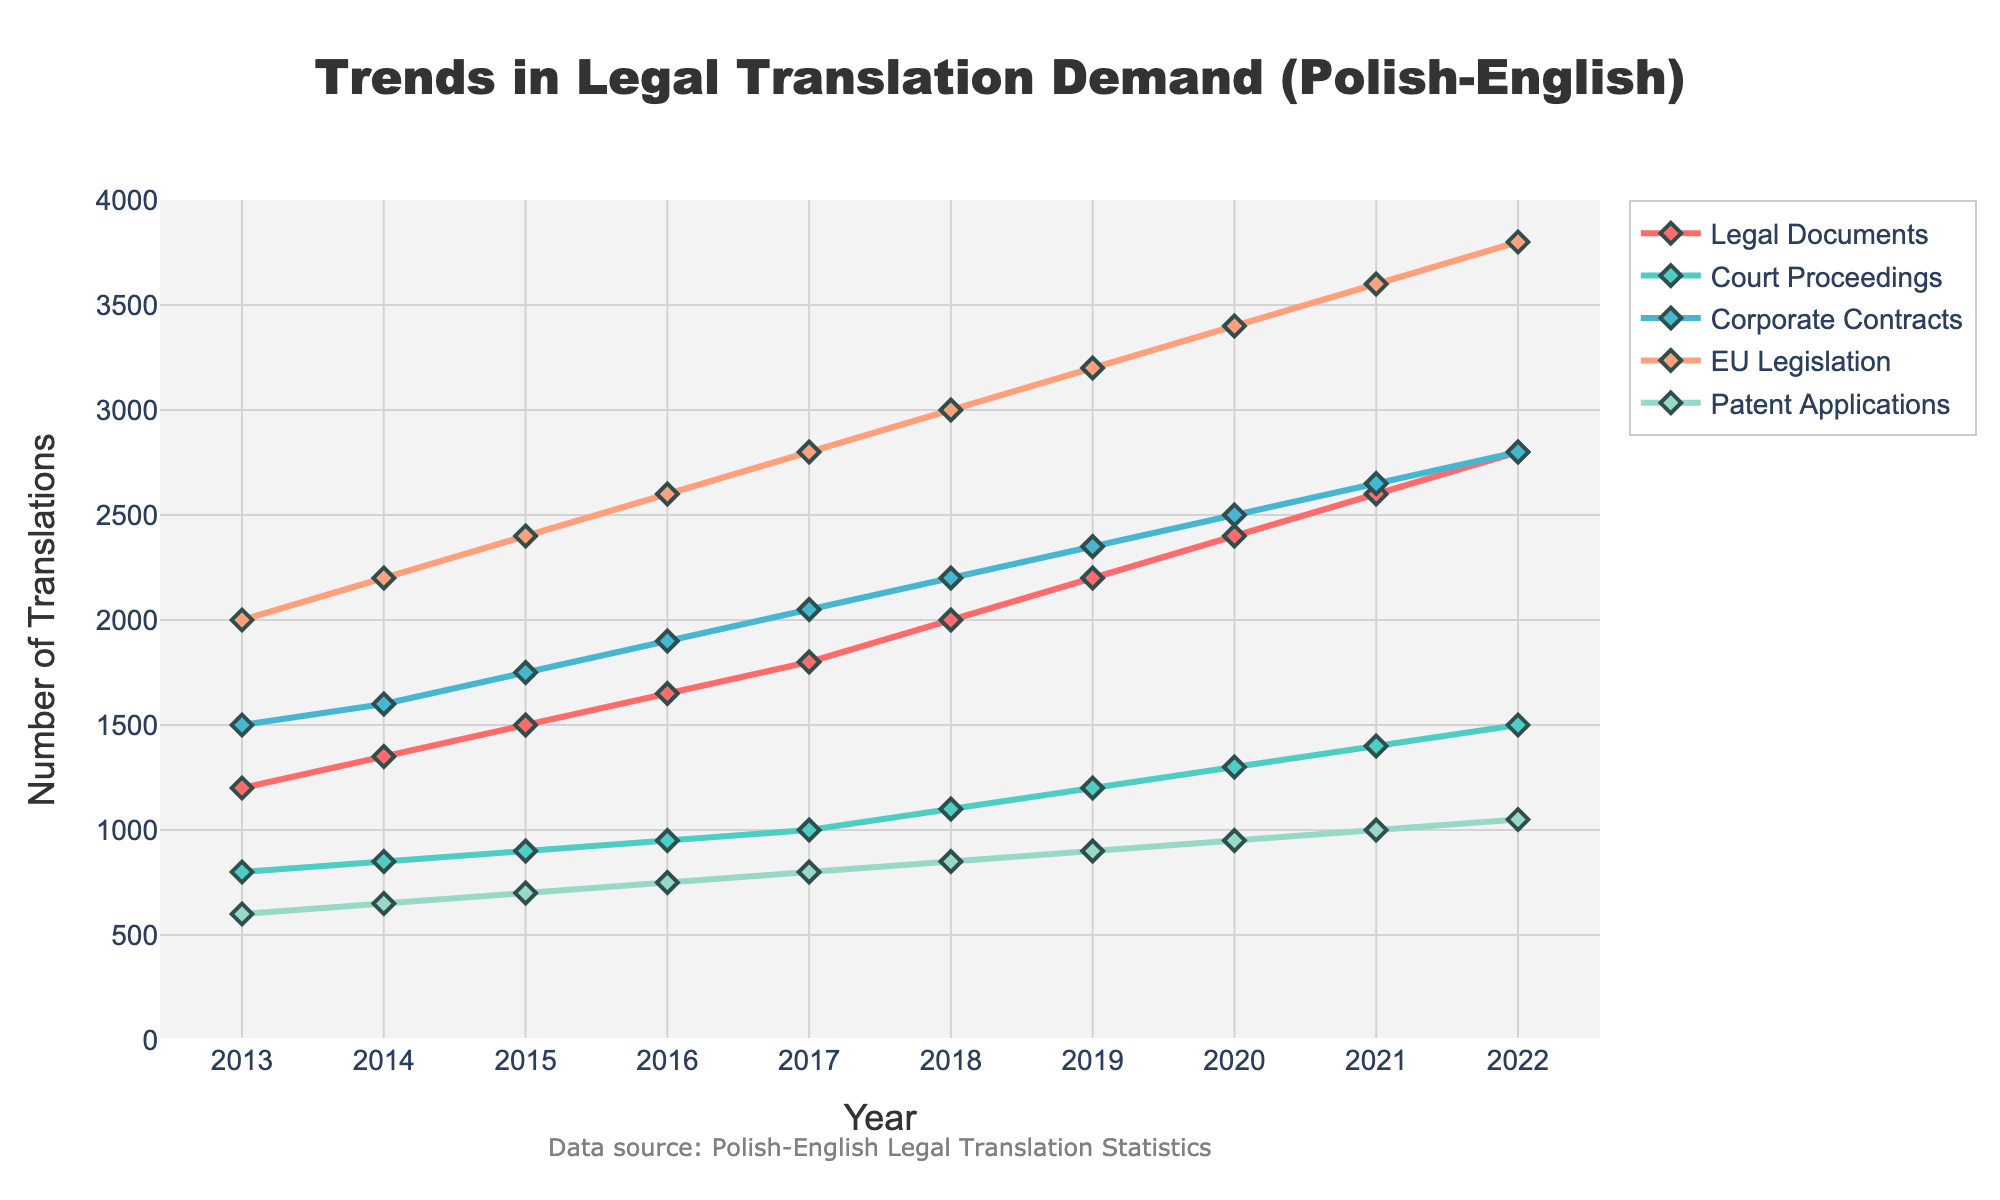what is the overall trend of EU Legislation translations from 2013 to 2022? To determine the overall trend, look at the EU Legislation line over the years from 2013 to 2022. Observe that it starts at around 2000 in 2013 and rises consistently each year, reaching about 3800 in 2022.
Answer: Increasing which category saw the largest growth in demand between 2013 and 2022? To find the largest growth, calculate the difference between the number of translations in 2022 and 2013 for each category. The changes are: 
Legal Documents: 2800-1200 = 1600 
Court Proceedings: 1500-800 = 700 
Corporate Contracts: 2800-1500 = 1300 
EU Legislation: 3800-2000 = 1800 
Patent Applications: 1050-600 = 450. The largest growth occurred in EU Legislation.
Answer: EU Legislation between 2020 and 2022, did any category's translation demand remain constant? To check for constant demand, compare the translation numbers in 2020 and 2022 for each category. Notice that every category increased in demand, none remained constant.
Answer: No which category had the smallest number of translations in 2013? Examine the y-values of each category in 2013. The values are: 
Legal Documents: 1200 
Court Proceedings: 800 
Corporate Contracts: 1500 
EU Legislation: 2000 
Patent Applications: 600. The smallest number is for Patent Applications.
Answer: Patent Applications how much did the demand for Corporate Contracts translations grow from 2016 to 2020? Calculate the growth by subtracting the number of translations in 2016 from that in 2020. The demand in 2016 was 1900 and in 2020 it was 2500, so the growth is 2500 - 1900 = 600.
Answer: 600 which category had the highest translation demand in 2022? Look at the highest y-value in 2022 across all categories. Legal Documents: 2800 
Court Proceedings: 1500 
Corporate Contracts: 2800 
EU Legislation: 3800 
Patent Applications: 1050. The highest number is for EU Legislation.
Answer: EU Legislation what is the combined number of translations for Court Proceedings and Patent Applications in 2020? Add the values of Court Proceedings and Patent Applications in 2020. Court Proceedings: 1300 Patent Applications: 950 
1300 + 950 = 2250
Answer: 2250 When did Corporate Contracts translations cross the 2000 mark? Identify the first year when the number of Corporate Contracts translations exceeds 2000. In 2017, the value is 2050, which is the first time it crosses 2000.
Answer: 2017 What can be said about the proportion of EU Legislation translations in comparison to other categories in 2022? In 2022, EU Legislation stands at 3800, which is significantly higher compared to Legal Documents (2800), Court Proceedings (1500), Corporate Contracts (2800), and Patent Applications (1050). EU Legislation constitutes a major proportion of the translation demands in that year.
Answer: Major proportion in 2022 